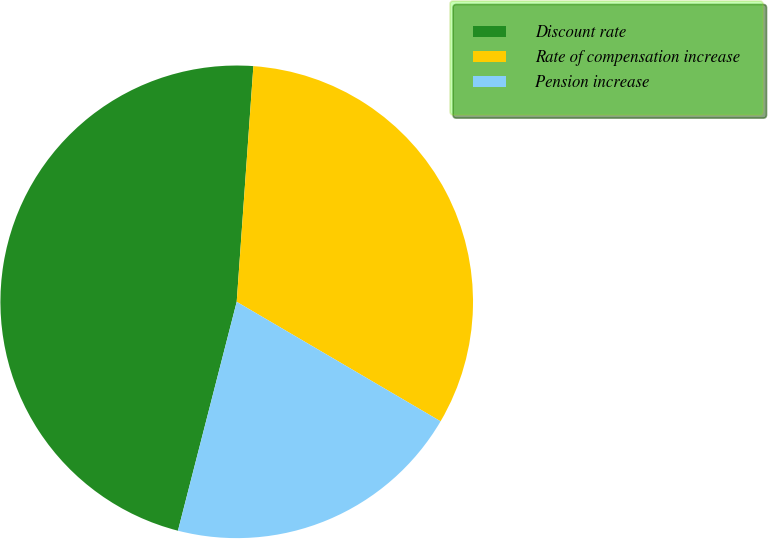<chart> <loc_0><loc_0><loc_500><loc_500><pie_chart><fcel>Discount rate<fcel>Rate of compensation increase<fcel>Pension increase<nl><fcel>47.12%<fcel>32.31%<fcel>20.56%<nl></chart> 